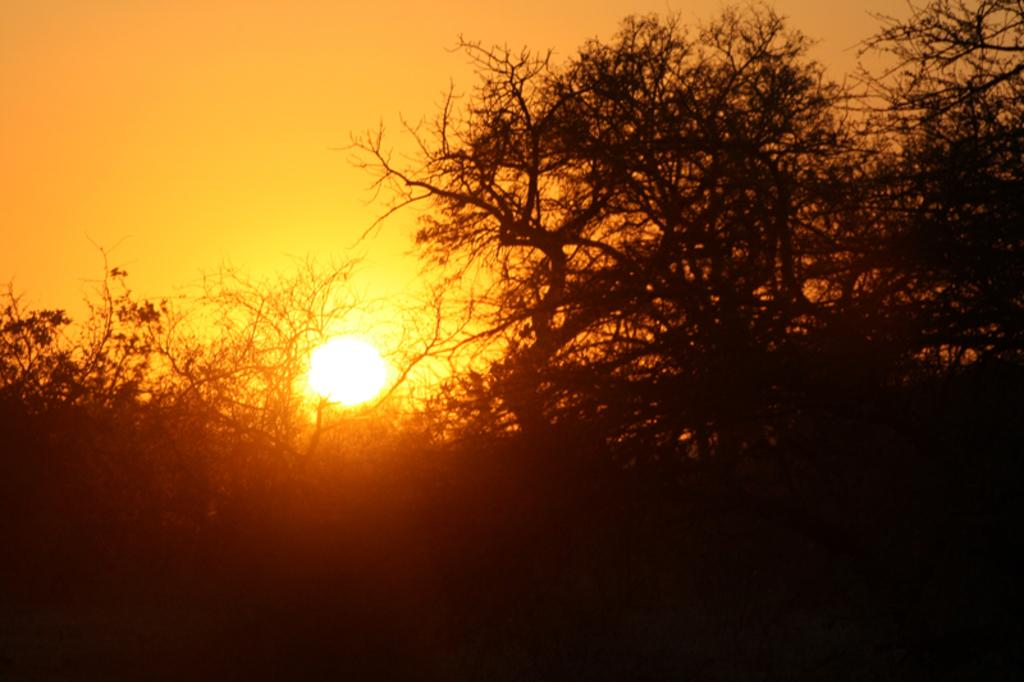What type of vegetation can be seen in the image? There are trees in the image. What is visible in the background of the image? The sky is visible in the background of the image. Can the sun be seen in the image? Yes, the sun is observable in the sky. What type of bottle is hanging from the tail of the wire in the image? There is no bottle or wire present in the image; it only features trees and the sky. 